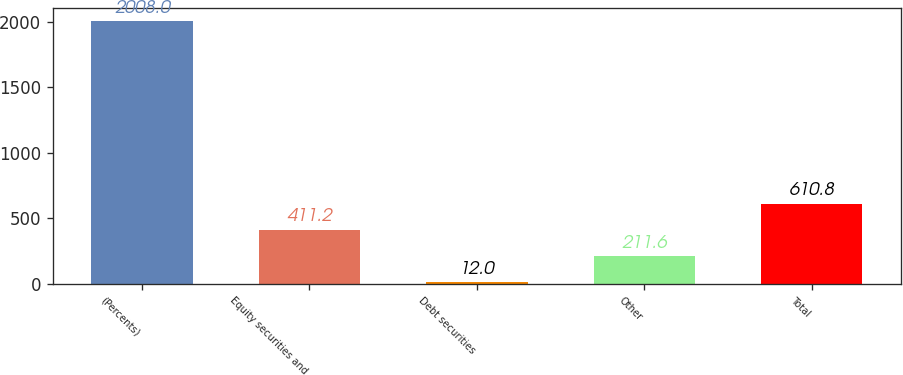Convert chart to OTSL. <chart><loc_0><loc_0><loc_500><loc_500><bar_chart><fcel>(Percents)<fcel>Equity securities and<fcel>Debt securities<fcel>Other<fcel>Total<nl><fcel>2008<fcel>411.2<fcel>12<fcel>211.6<fcel>610.8<nl></chart> 